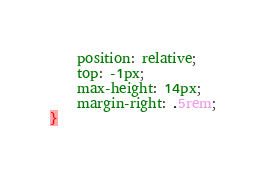<code> <loc_0><loc_0><loc_500><loc_500><_CSS_>	position: relative;
    top: -1px;
    max-height: 14px;
    margin-right: .5rem;
}</code> 